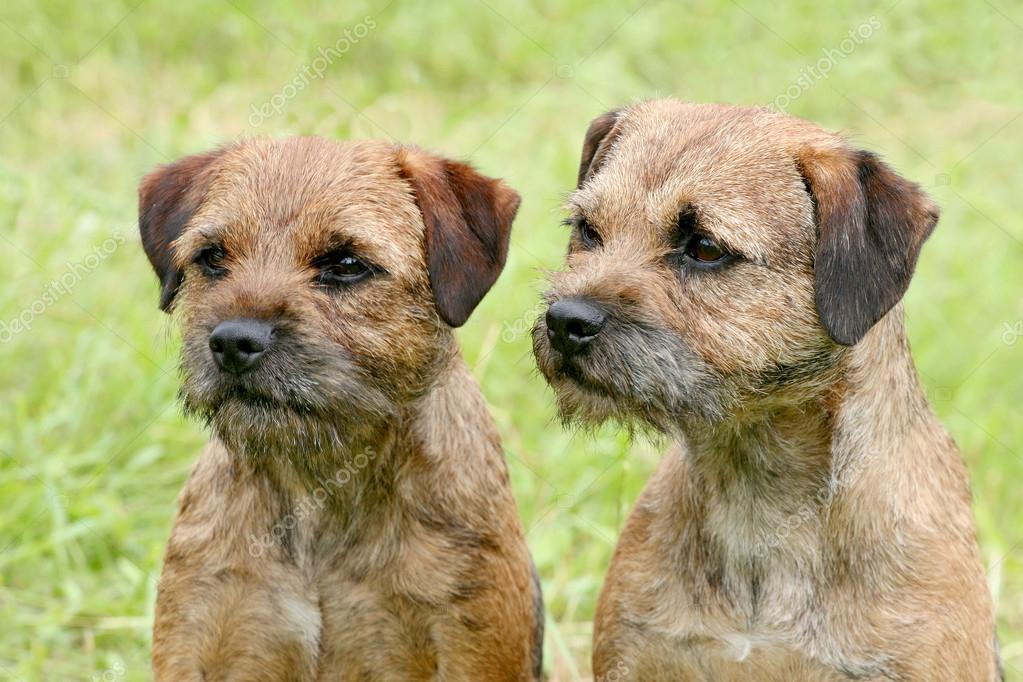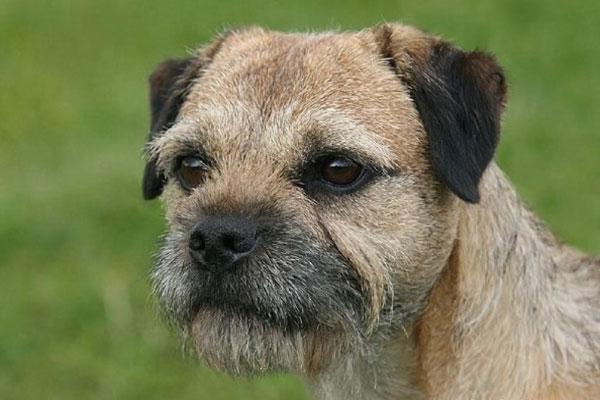The first image is the image on the left, the second image is the image on the right. Given the left and right images, does the statement "In one of the images, two border terriers are sitting next to each other." hold true? Answer yes or no. Yes. The first image is the image on the left, the second image is the image on the right. Assess this claim about the two images: "One image contains twice as many dogs as the other image, and in total, at least two of the dogs depicted face the same direction.". Correct or not? Answer yes or no. Yes. 